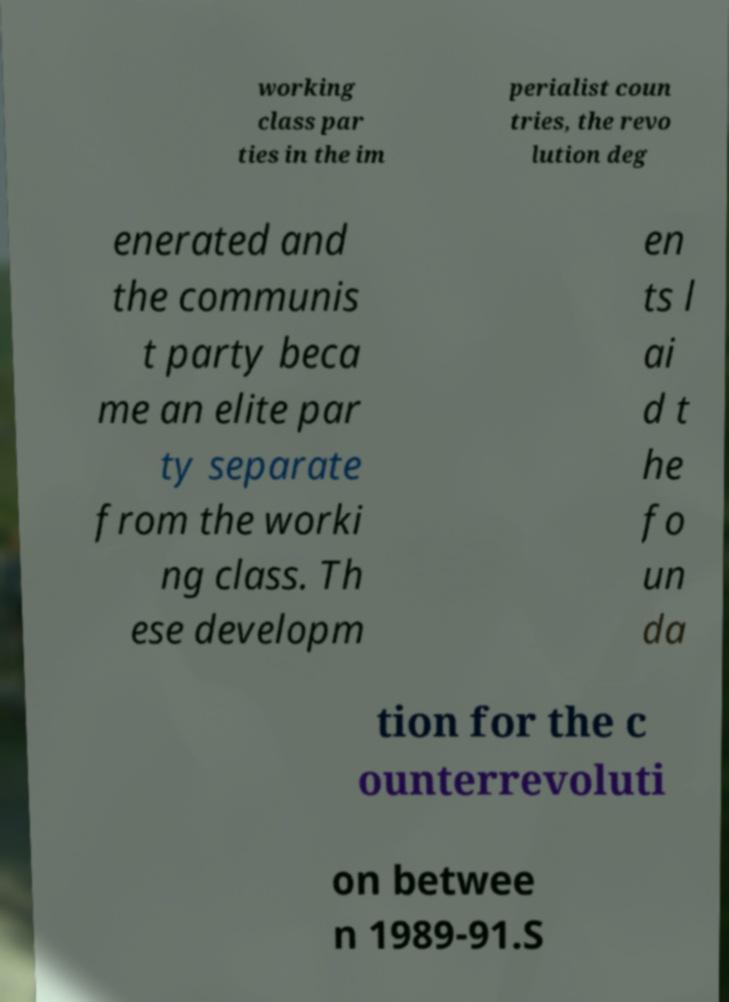Can you accurately transcribe the text from the provided image for me? working class par ties in the im perialist coun tries, the revo lution deg enerated and the communis t party beca me an elite par ty separate from the worki ng class. Th ese developm en ts l ai d t he fo un da tion for the c ounterrevoluti on betwee n 1989-91.S 